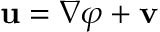Convert formula to latex. <formula><loc_0><loc_0><loc_500><loc_500>u = \nabla \varphi + v</formula> 